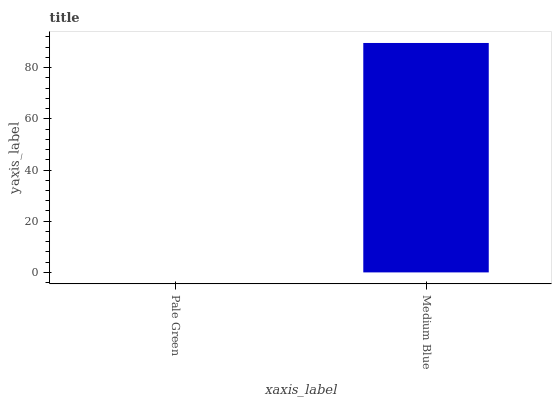Is Pale Green the minimum?
Answer yes or no. Yes. Is Medium Blue the maximum?
Answer yes or no. Yes. Is Medium Blue the minimum?
Answer yes or no. No. Is Medium Blue greater than Pale Green?
Answer yes or no. Yes. Is Pale Green less than Medium Blue?
Answer yes or no. Yes. Is Pale Green greater than Medium Blue?
Answer yes or no. No. Is Medium Blue less than Pale Green?
Answer yes or no. No. Is Medium Blue the high median?
Answer yes or no. Yes. Is Pale Green the low median?
Answer yes or no. Yes. Is Pale Green the high median?
Answer yes or no. No. Is Medium Blue the low median?
Answer yes or no. No. 